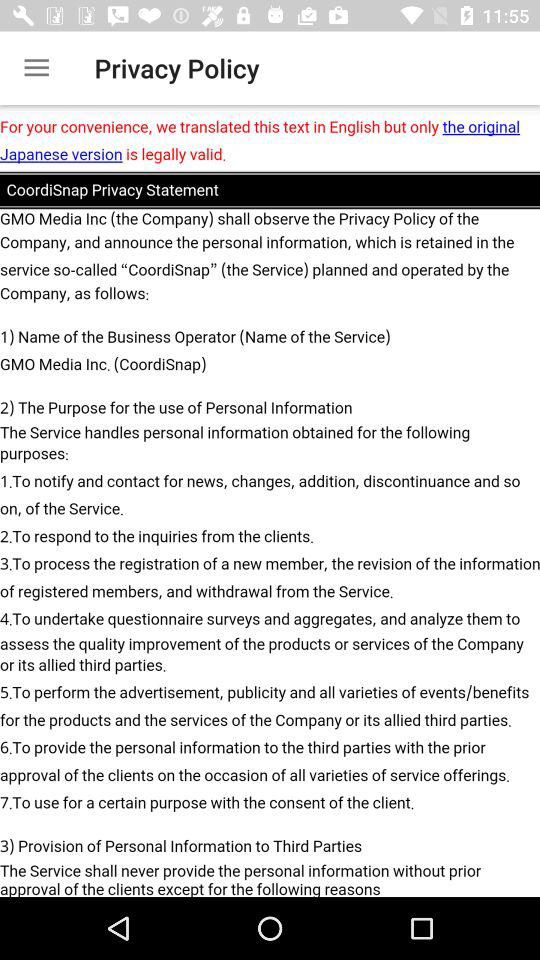How many purposes are there for using personal information?
Answer the question using a single word or phrase. 7 